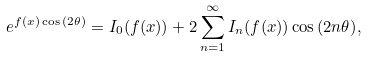<formula> <loc_0><loc_0><loc_500><loc_500>e ^ { f ( x ) \cos { ( 2 \theta ) } } = I _ { 0 } ( f ( x ) ) + 2 \sum ^ { \infty } _ { n = 1 } I _ { n } ( f ( x ) ) \cos { ( 2 n \theta ) } ,</formula> 